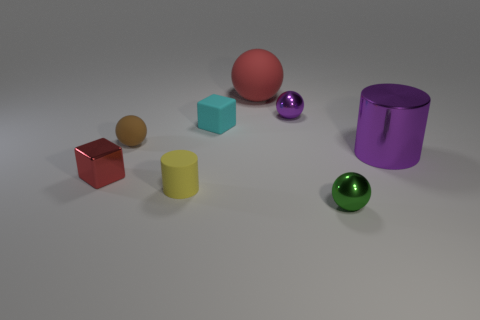Can you tell me the colors of the spherical objects? Certainly! The image contains two spherical objects, one is brown and the other is green. 